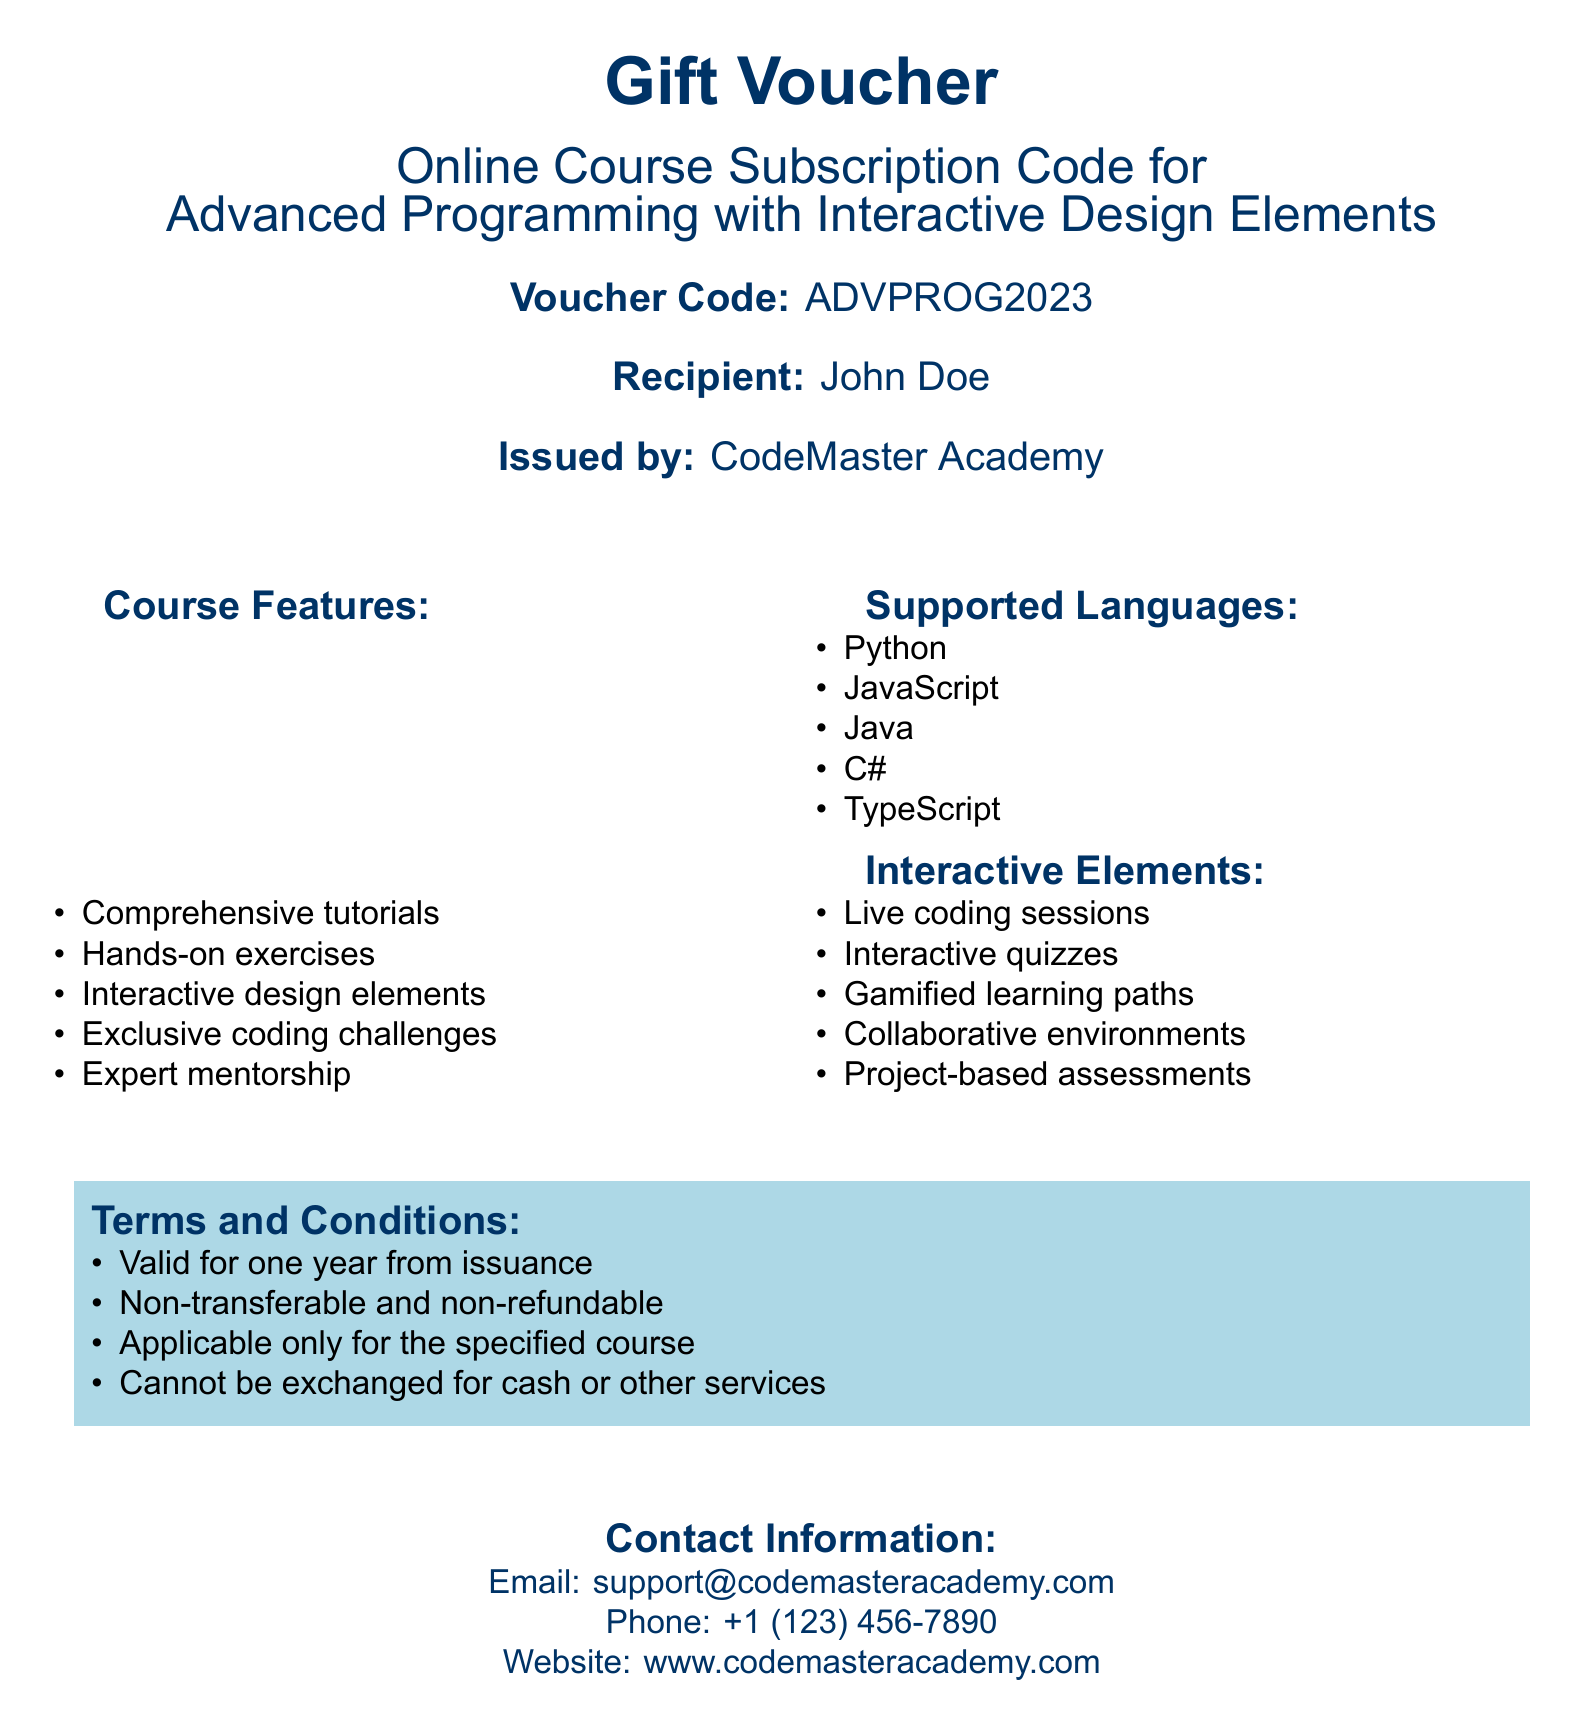What is the voucher code? The voucher code is mentioned clearly in the document.
Answer: ADVPROG2023 Who is the recipient of the voucher? The document specifies the name of the recipient.
Answer: John Doe Which organization issued the voucher? The name of the issuing organization is stated.
Answer: CodeMaster Academy How many supported programming languages are mentioned in the document? Counting the languages listed gives the total number of supported languages.
Answer: 5 What type of elements are included in the course? The document lists several features regarding course elements.
Answer: Interactive design elements What is the validity period of the voucher? The document details the terms regarding the validity of the voucher.
Answer: One year What is the nature of the voucher in terms of transferability? The conditions state specific details about the voucher's transferability.
Answer: Non-transferable Can the voucher be exchanged for cash? The terms clearly stipulate whether the voucher can be exchanged.
Answer: No 